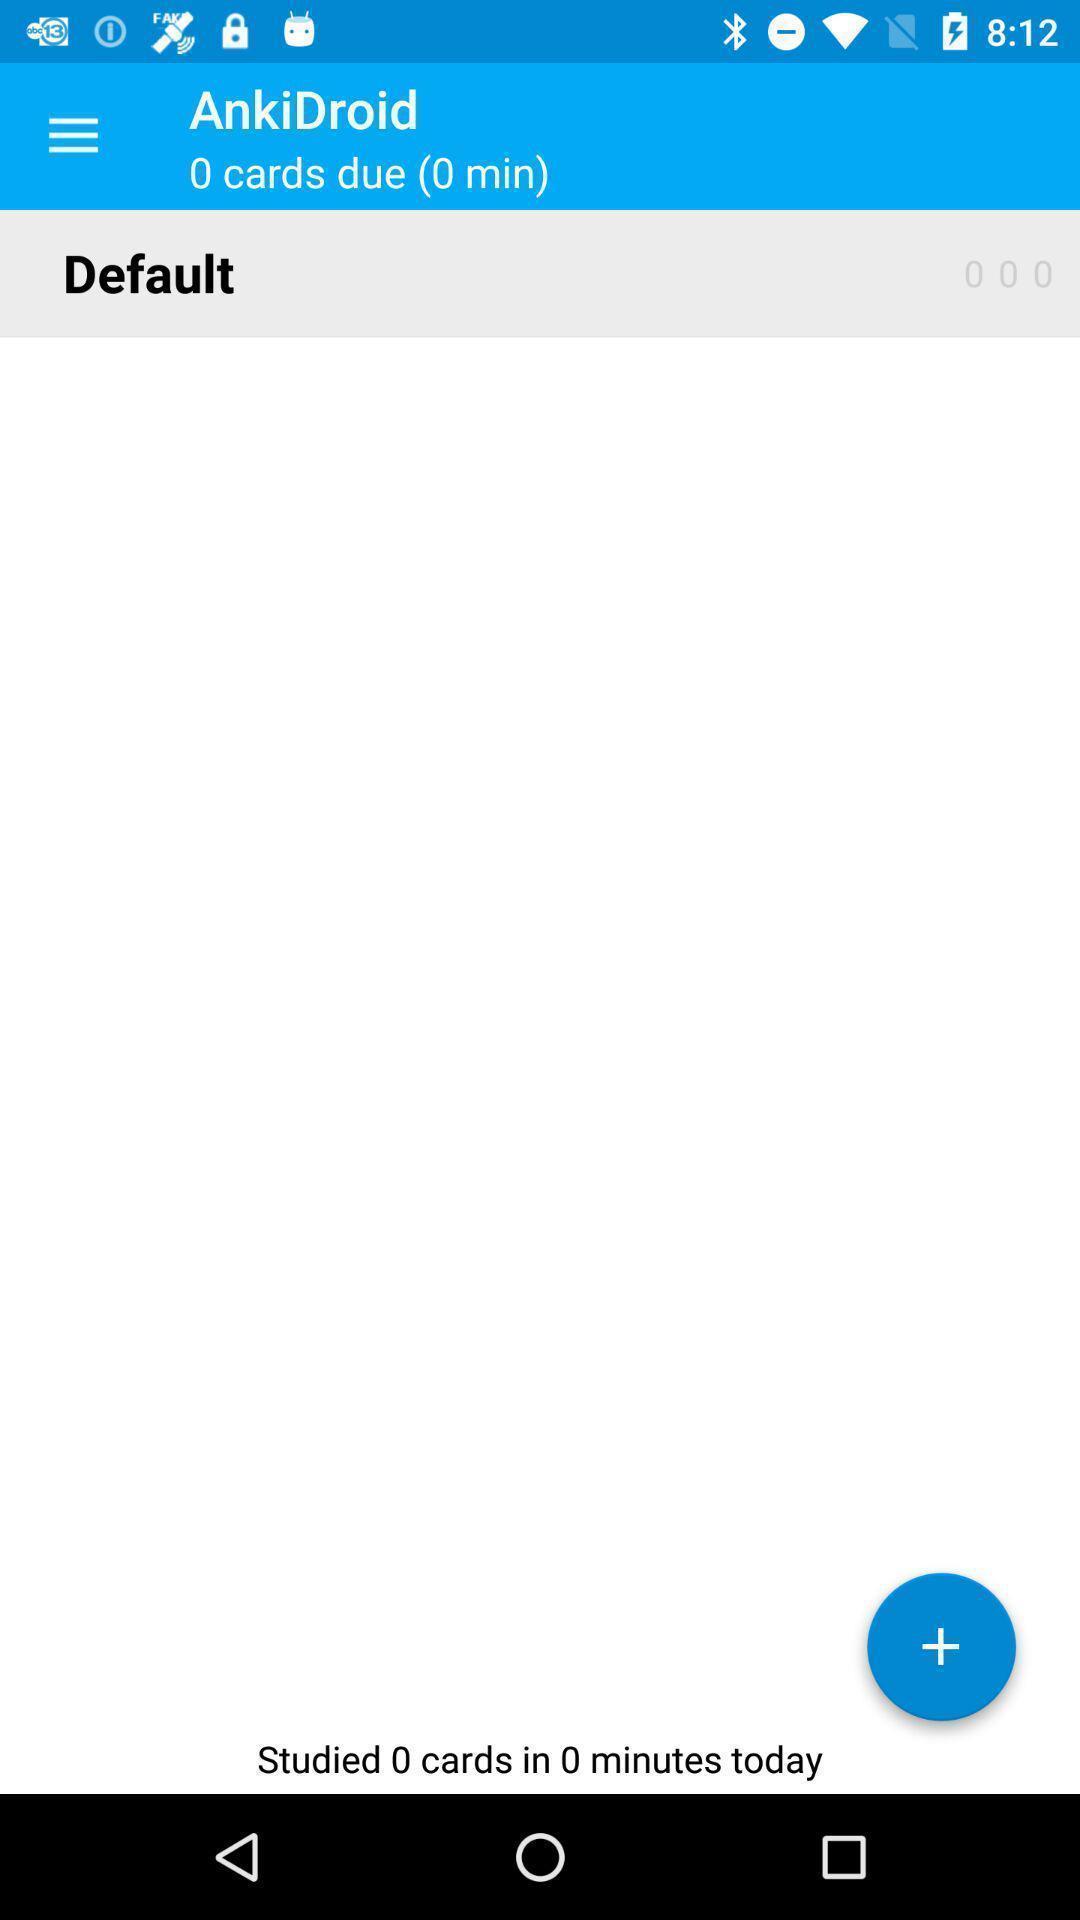Describe the content in this image. Screen shows cards information. 